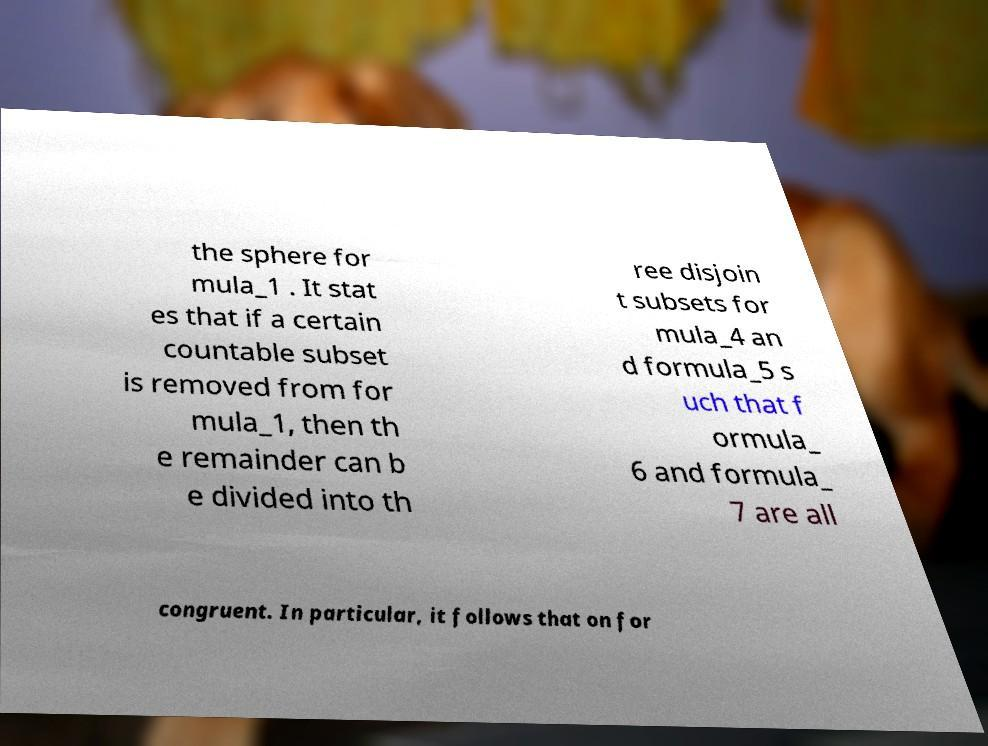Please read and relay the text visible in this image. What does it say? the sphere for mula_1 . It stat es that if a certain countable subset is removed from for mula_1, then th e remainder can b e divided into th ree disjoin t subsets for mula_4 an d formula_5 s uch that f ormula_ 6 and formula_ 7 are all congruent. In particular, it follows that on for 